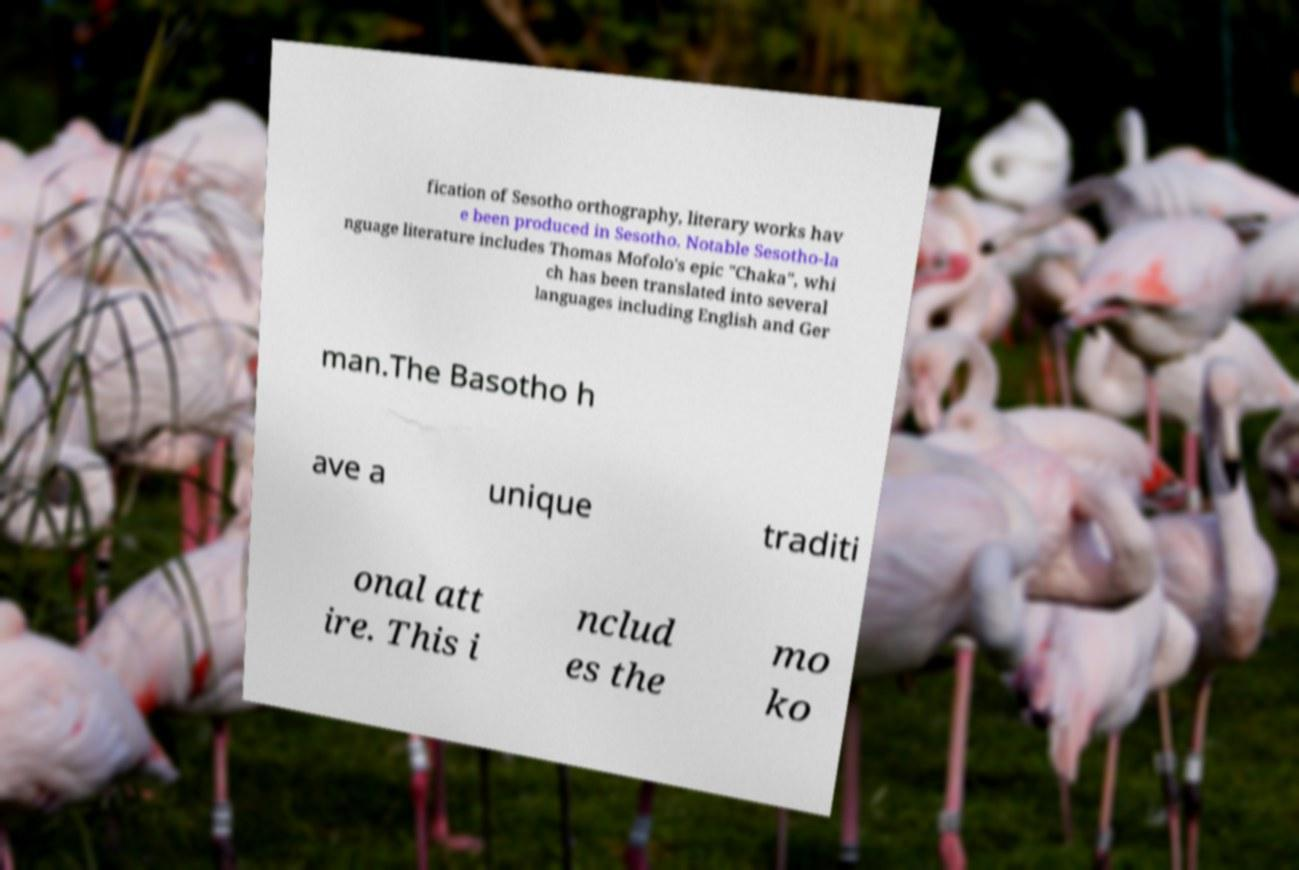Can you read and provide the text displayed in the image?This photo seems to have some interesting text. Can you extract and type it out for me? fication of Sesotho orthography, literary works hav e been produced in Sesotho. Notable Sesotho-la nguage literature includes Thomas Mofolo's epic "Chaka", whi ch has been translated into several languages including English and Ger man.The Basotho h ave a unique traditi onal att ire. This i nclud es the mo ko 